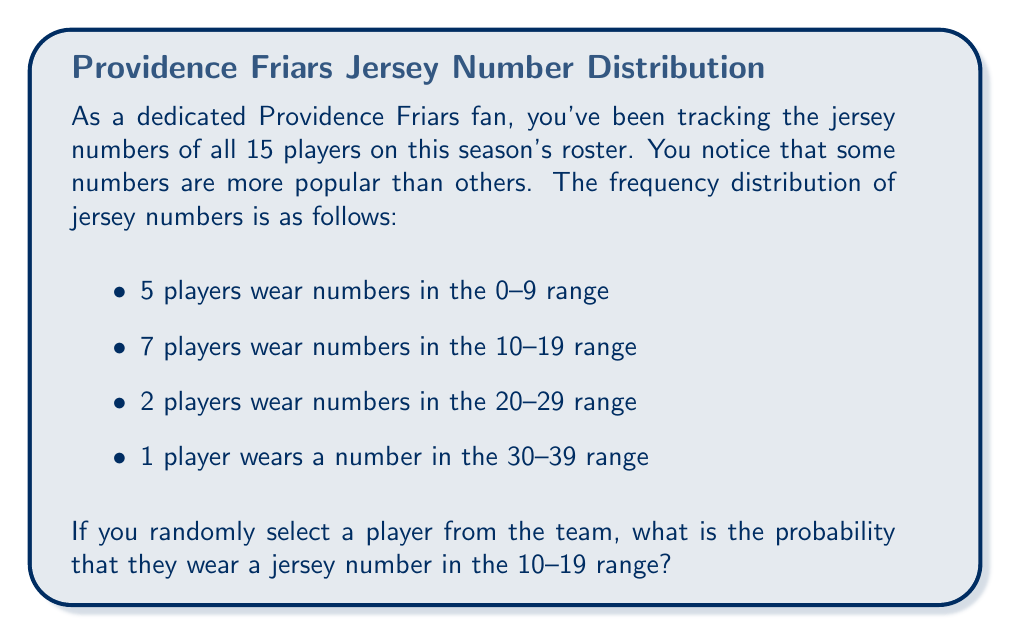Give your solution to this math problem. To solve this problem, we need to use the concept of probability based on frequency distribution. The probability of an event occurring is the number of favorable outcomes divided by the total number of possible outcomes.

Let's break down the solution:

1. Total number of players on the roster:
   $$ 5 + 7 + 2 + 1 = 15 $$

2. Number of players wearing jersey numbers in the 10-19 range: 7

3. Probability calculation:
   $$ P(\text{10-19 range}) = \frac{\text{Number of favorable outcomes}}{\text{Total number of outcomes}} $$
   $$ P(\text{10-19 range}) = \frac{7}{15} $$

4. Simplify the fraction:
   $$ P(\text{10-19 range}) = \frac{7}{15} $$

This fraction cannot be reduced further, so our final answer is $\frac{7}{15}$.
Answer: $\frac{7}{15}$ 